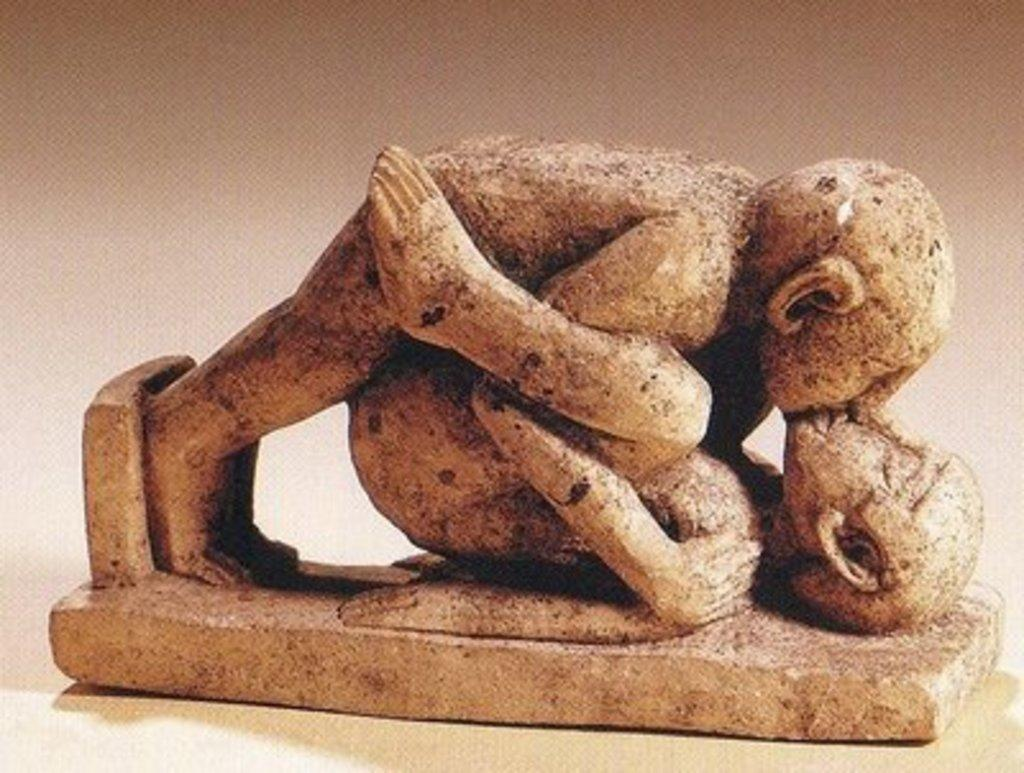What is the main subject of the image? The main subject of the image is a statue. What does the statue depict? The statue depicts persons. What are the persons in the statue doing? The persons in the statue are doing some work. What type of observation can be made about the sheet in the image? There is no sheet present in the image; it only features a statue depicting persons doing some work. 